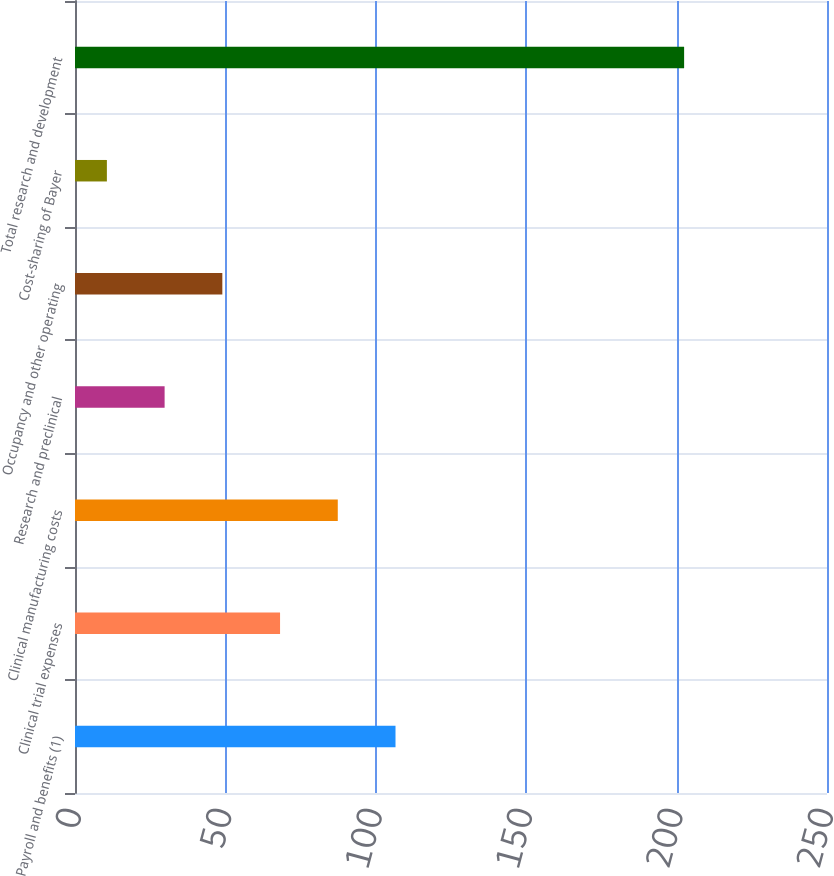Convert chart. <chart><loc_0><loc_0><loc_500><loc_500><bar_chart><fcel>Payroll and benefits (1)<fcel>Clinical trial expenses<fcel>Clinical manufacturing costs<fcel>Research and preclinical<fcel>Occupancy and other operating<fcel>Cost-sharing of Bayer<fcel>Total research and development<nl><fcel>106.55<fcel>68.17<fcel>87.36<fcel>29.79<fcel>48.98<fcel>10.6<fcel>202.5<nl></chart> 